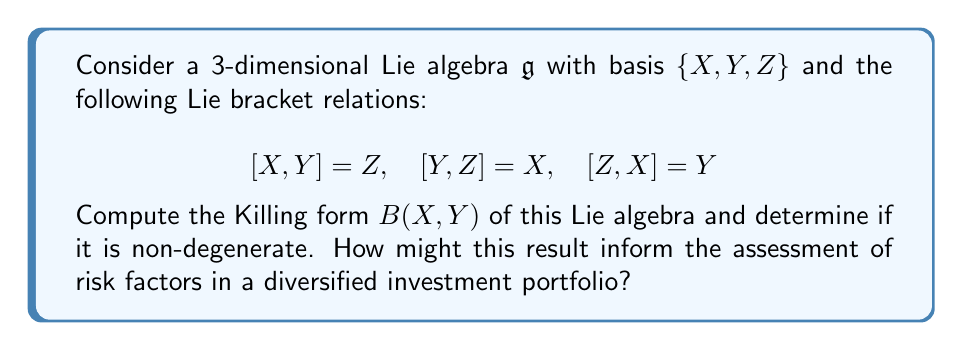What is the answer to this math problem? To compute the Killing form and assess its degeneracy, we'll follow these steps:

1) The Killing form is defined as $B(X,Y) = \text{tr}(\text{ad}_X \circ \text{ad}_Y)$, where $\text{ad}_X$ is the adjoint representation of $X$.

2) First, let's compute the adjoint representations of $X$, $Y$, and $Z$:

   $\text{ad}_X = \begin{pmatrix} 0 & 0 & -1 \\ 0 & 0 & 1 \\ 0 & -1 & 0 \end{pmatrix}$
   
   $\text{ad}_Y = \begin{pmatrix} 0 & 0 & 1 \\ 0 & 0 & -1 \\ -1 & 0 & 0 \end{pmatrix}$
   
   $\text{ad}_Z = \begin{pmatrix} 0 & -1 & 0 \\ 1 & 0 & 0 \\ 0 & 0 & 0 \end{pmatrix}$

3) Now, we compute $B(X,X)$, $B(Y,Y)$, and $B(Z,Z)$:

   $B(X,X) = \text{tr}(\text{ad}_X \circ \text{ad}_X) = -2$
   $B(Y,Y) = \text{tr}(\text{ad}_Y \circ \text{ad}_Y) = -2$
   $B(Z,Z) = \text{tr}(\text{ad}_Z \circ \text{ad}_Z) = -2$

4) For the off-diagonal elements:

   $B(X,Y) = B(Y,X) = \text{tr}(\text{ad}_X \circ \text{ad}_Y) = 0$
   $B(X,Z) = B(Z,X) = \text{tr}(\text{ad}_X \circ \text{ad}_Z) = 0$
   $B(Y,Z) = B(Z,Y) = \text{tr}(\text{ad}_Y \circ \text{ad}_Z) = 0$

5) Therefore, the Killing form matrix is:

   $$B = \begin{pmatrix} -2 & 0 & 0 \\ 0 & -2 & 0 \\ 0 & 0 & -2 \end{pmatrix}$$

6) The determinant of this matrix is $-8 \neq 0$, so the Killing form is non-degenerate.

In the context of investment strategy, this non-degenerate Killing form suggests a robust structure in the underlying mathematical model. For a seasoned investor, this could be interpreted as follows:

1) The non-degeneracy indicates that the risk factors (represented by the basis elements) are linearly independent, suggesting a well-diversified portfolio structure.

2) The symmetry in the Killing form (-2 on all diagonal elements) suggests that each risk factor contributes equally to the overall risk profile, which could indicate a balanced risk distribution.

3) The zero off-diagonal elements imply that the risk factors are orthogonal to each other, potentially indicating effective diversification with minimal correlation between different investment strategies.

These mathematical properties could translate to a robust and well-balanced investment strategy, potentially offering good risk management characteristics. However, it's crucial to note that this mathematical model is a simplification and should be complemented with real-world financial data and expert analysis for comprehensive risk assessment.
Answer: The Killing form of the given Lie algebra is:

$$B = \begin{pmatrix} -2 & 0 & 0 \\ 0 & -2 & 0 \\ 0 & 0 & -2 \end{pmatrix}$$

This Killing form is non-degenerate, as its determinant is $-8 \neq 0$. This result suggests a well-structured, balanced, and potentially well-diversified investment strategy with orthogonal risk factors. 